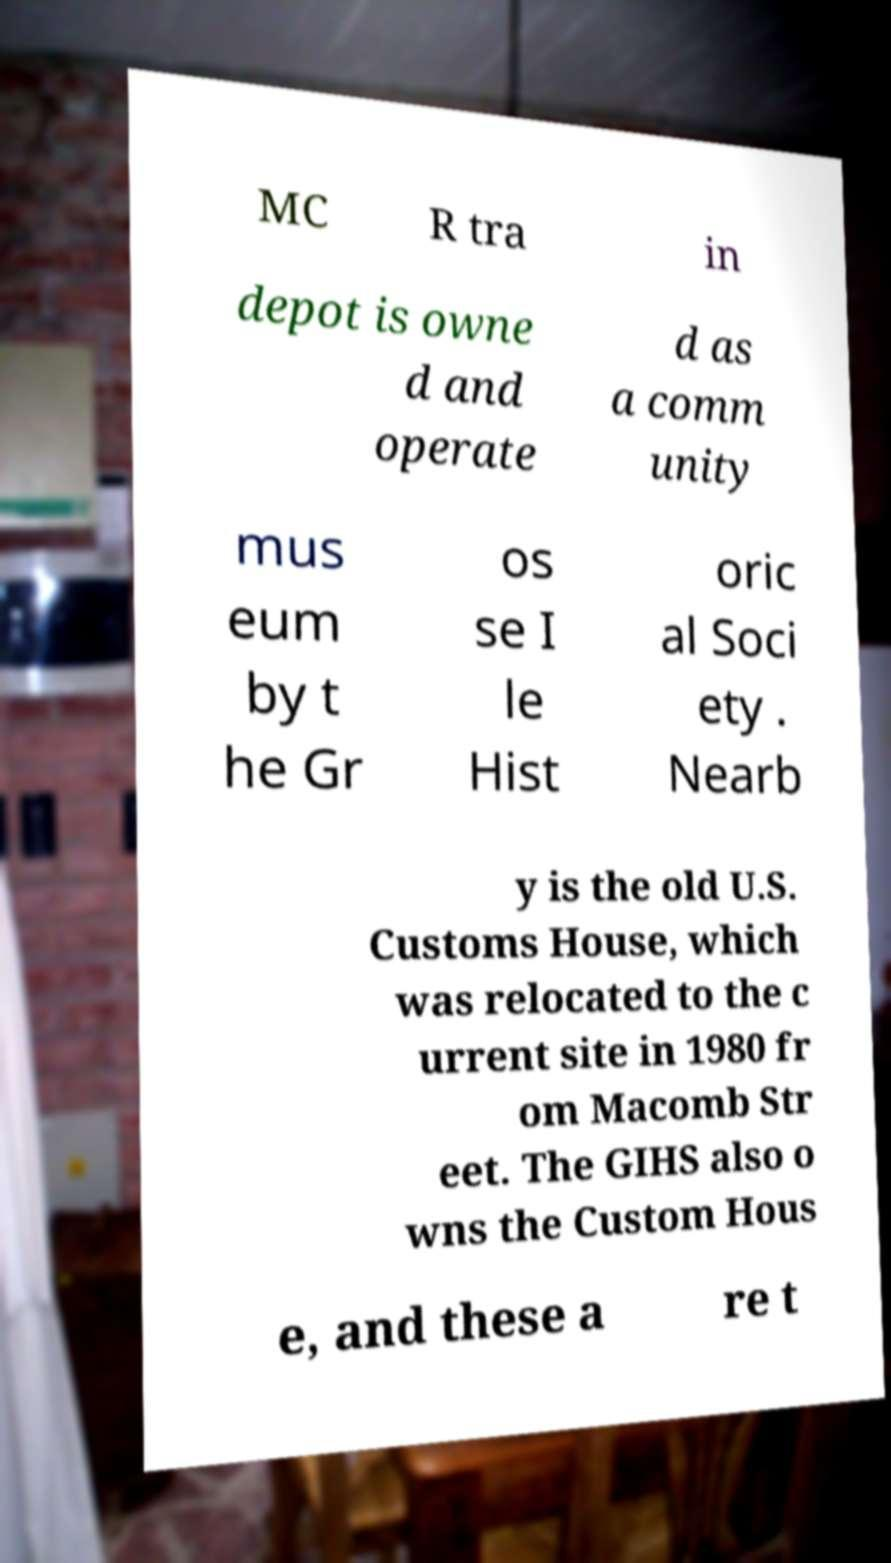I need the written content from this picture converted into text. Can you do that? MC R tra in depot is owne d and operate d as a comm unity mus eum by t he Gr os se I le Hist oric al Soci ety . Nearb y is the old U.S. Customs House, which was relocated to the c urrent site in 1980 fr om Macomb Str eet. The GIHS also o wns the Custom Hous e, and these a re t 